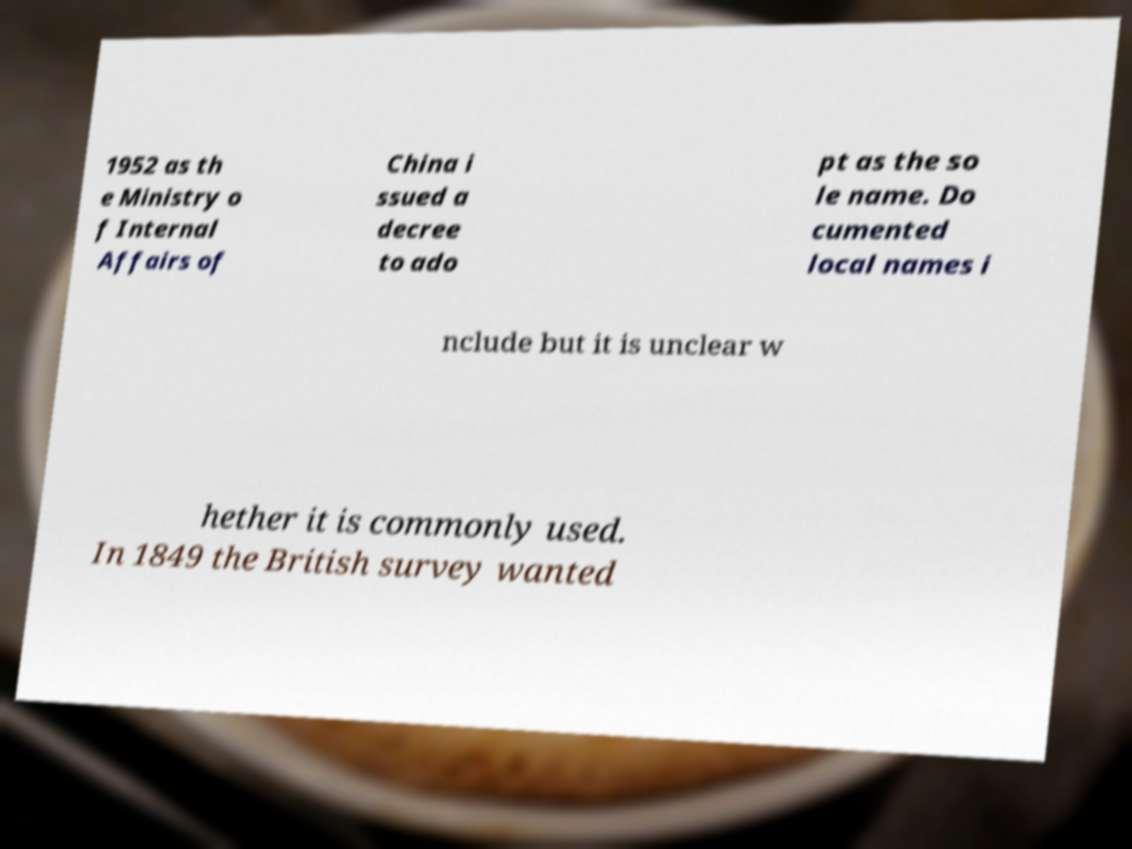Could you extract and type out the text from this image? 1952 as th e Ministry o f Internal Affairs of China i ssued a decree to ado pt as the so le name. Do cumented local names i nclude but it is unclear w hether it is commonly used. In 1849 the British survey wanted 